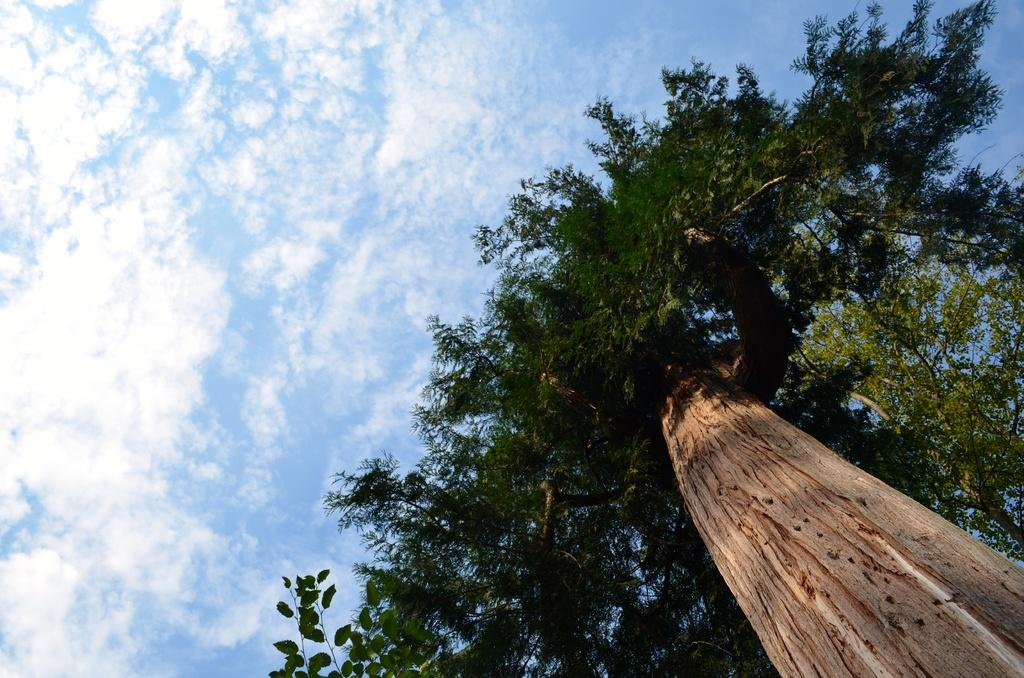What type of plant can be seen in the image? There is a tree in the image. What part of the tree is visible in the image? The tree trunk is visible in the image. What is the condition of the sky in the image? The sky is cloudy in the image. What type of pear is hanging from the tree in the image? There is no pear present in the image; it only features a tree with a visible trunk. What color is the chalk used to draw on the tree in the image? There is no chalk or drawing on the tree in the image; it only shows a tree with a visible trunk and a cloudy sky. 